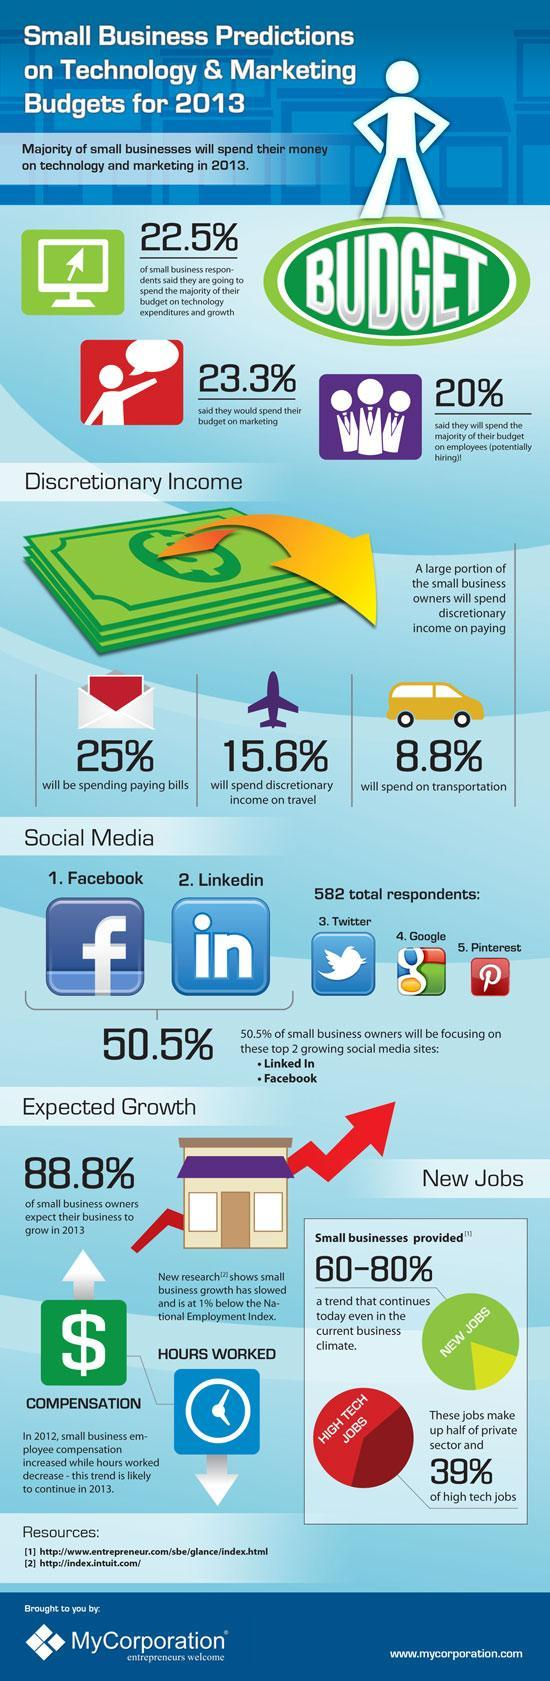What percentage of the new jobs are high tech jobs?
Answer the question with a short phrase. 39% What percent of the small business owners expect their business to grow in 2013? 88.8% What are majority of the respondents spending their discretionary income on? Paying bills What is the percentage of new jobs provided by small businesses? 60-80% Which is the 4th social media preferred by the respondents? Google Which are the two major social media platforms that small business owners prefer? Facebook, LinkedIn What percent of the respondents intent to spend majority of their budget on technology? 22.5% How many social media platforms are mentioned here? 5 What percent of the respondents are spending their discretionary income on travel? 15.6% Which is the social media site represented by the letter 'P'? Pinterest What percent of the respondents focus on Facebook and LinkedIn? 50.5% What percent of respondents intent to spend majority of their budget on marketing? 23.3% 